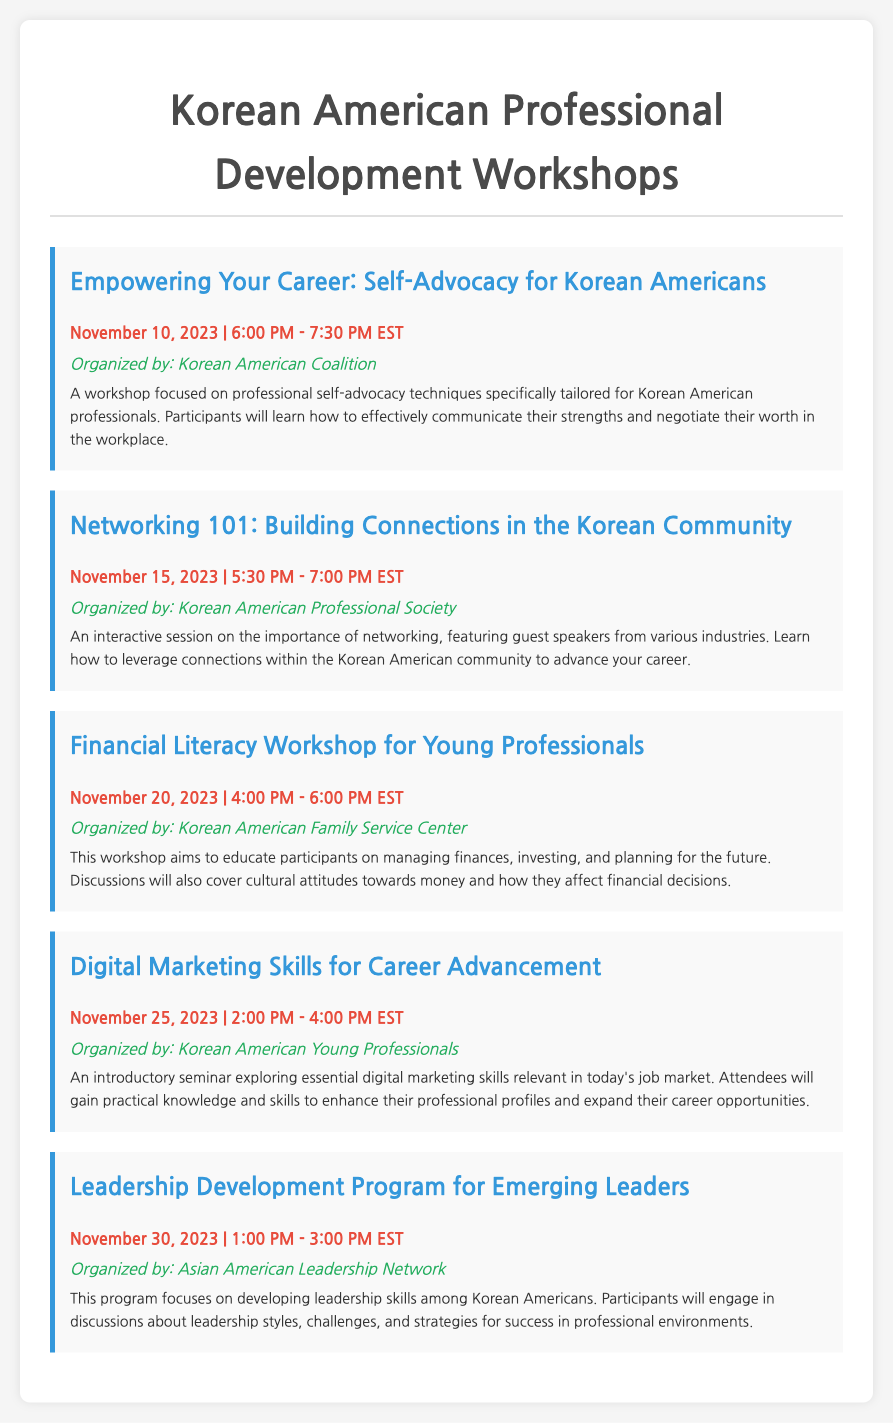what is the title of the first workshop? The title of the first workshop is provided in the document under the workshop section, stating "Empowering Your Career: Self-Advocacy for Korean Americans."
Answer: Empowering Your Career: Self-Advocacy for Korean Americans who is organizing the Financial Literacy Workshop? The organizing organization for the Financial Literacy Workshop is mentioned in the document, specifying the name of the organization responsible.
Answer: Korean American Family Service Center how many workshops are scheduled in November? The document provides a list of workshops, and by counting the entries, the total number of workshops for the month is determined.
Answer: Five what is the focus of the Digital Marketing Skills workshop? The document presents a description of the Digital Marketing Skills workshop, indicating the main subject of the session.
Answer: Essential digital marketing skills what is the duration of the Leadership Development Program? The document states the starting and ending times of the workshop, allowing for the calculation of its duration.
Answer: 2 hours which organization is hosting the workshop on self-advocacy? The organizing entity for the workshop focused on self-advocacy is mentioned in the document, highlighting its role.
Answer: Korean American Coalition what type of program is the last workshop classified as? The classification of the last workshop is provided in the document, specifying its nature based on the intended audience and purpose.
Answer: Leadership Development Program 